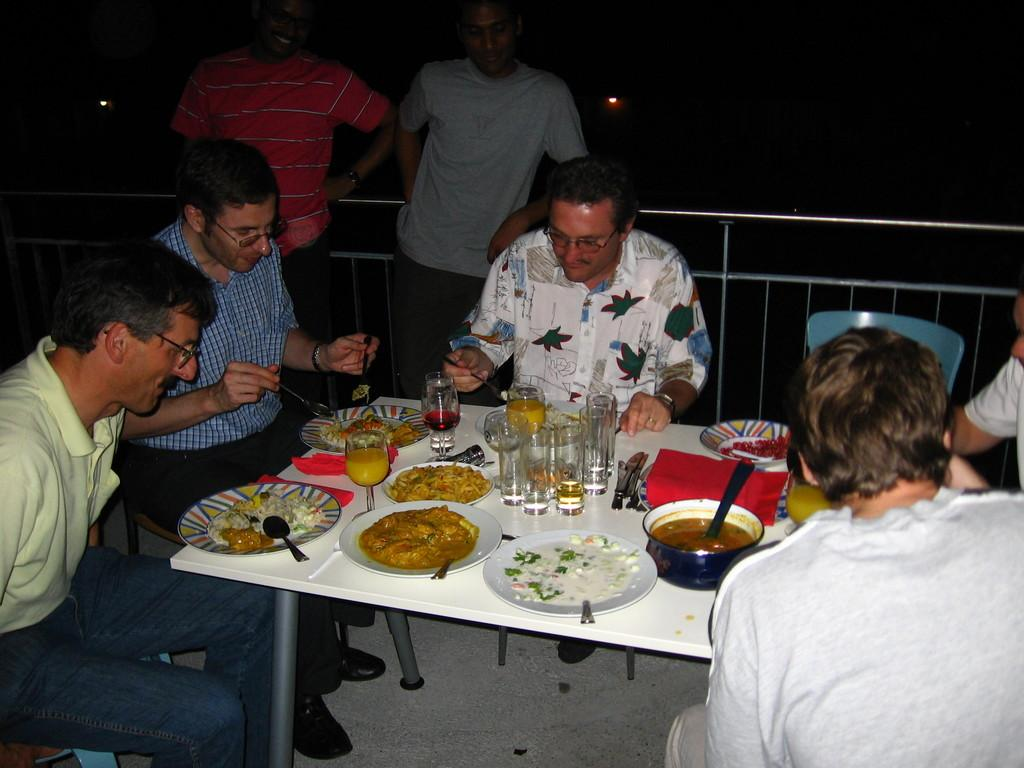How many people are present in the image? There are two people standing and five people sitting in the image, making a total of seven people. What are the people sitting on? The people sitting are on chairs in the image. What is on the table in the image? There are plates, glasses, and spoons on the table in the image. What type of bulb is being used for the chess game in the image? There is no bulb or chess game present in the image. Is the bat visible in the image? There is no bat present in the image. 